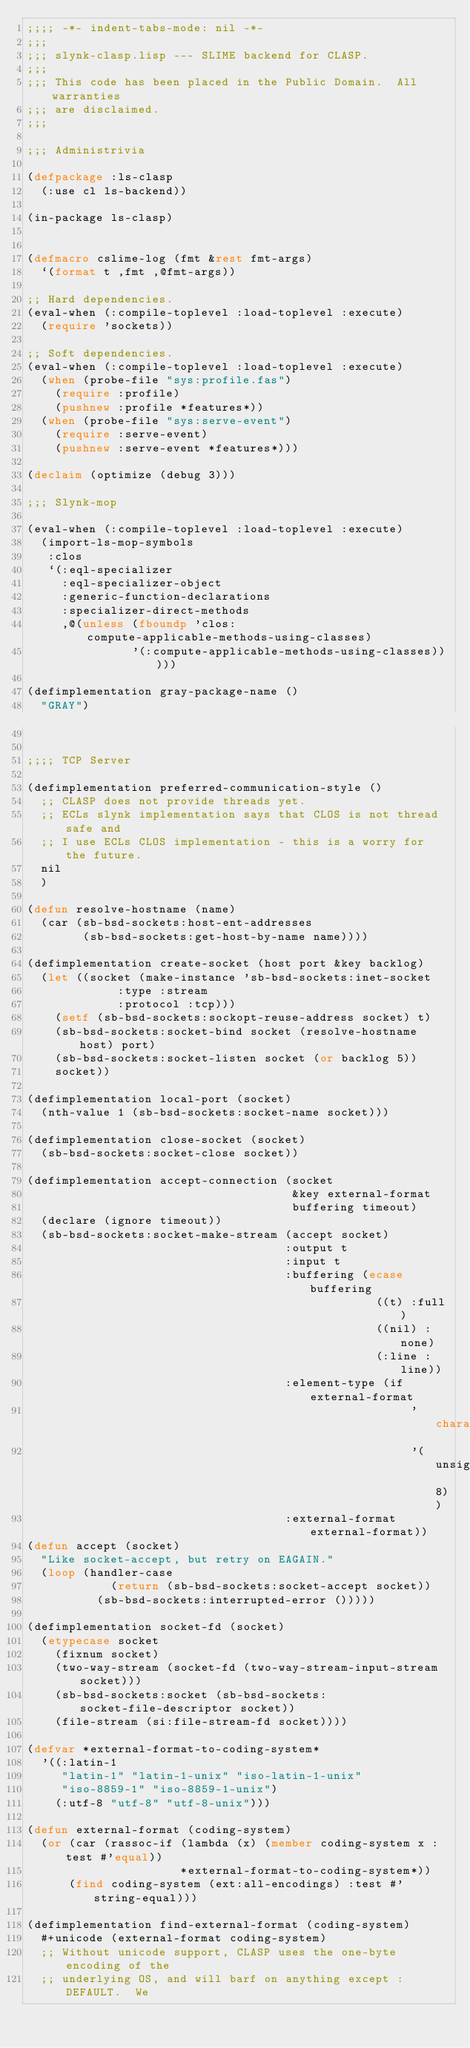Convert code to text. <code><loc_0><loc_0><loc_500><loc_500><_Lisp_>;;;; -*- indent-tabs-mode: nil -*-
;;;
;;; slynk-clasp.lisp --- SLIME backend for CLASP.
;;;
;;; This code has been placed in the Public Domain.  All warranties
;;; are disclaimed.
;;;

;;; Administrivia

(defpackage :ls-clasp
  (:use cl ls-backend))

(in-package ls-clasp)


(defmacro cslime-log (fmt &rest fmt-args)
  `(format t ,fmt ,@fmt-args))

;; Hard dependencies.
(eval-when (:compile-toplevel :load-toplevel :execute)
  (require 'sockets))

;; Soft dependencies.
(eval-when (:compile-toplevel :load-toplevel :execute)
  (when (probe-file "sys:profile.fas")
    (require :profile)
    (pushnew :profile *features*))
  (when (probe-file "sys:serve-event")
    (require :serve-event)
    (pushnew :serve-event *features*)))

(declaim (optimize (debug 3)))

;;; Slynk-mop

(eval-when (:compile-toplevel :load-toplevel :execute)
  (import-ls-mop-symbols
   :clos
   `(:eql-specializer
     :eql-specializer-object
     :generic-function-declarations
     :specializer-direct-methods
     ,@(unless (fboundp 'clos:compute-applicable-methods-using-classes)
               '(:compute-applicable-methods-using-classes)))))

(defimplementation gray-package-name ()
  "GRAY")


;;;; TCP Server

(defimplementation preferred-communication-style ()
  ;; CLASP does not provide threads yet.
  ;; ECLs slynk implementation says that CLOS is not thread safe and
  ;; I use ECLs CLOS implementation - this is a worry for the future.
  nil
  )

(defun resolve-hostname (name)
  (car (sb-bsd-sockets:host-ent-addresses
        (sb-bsd-sockets:get-host-by-name name))))

(defimplementation create-socket (host port &key backlog)
  (let ((socket (make-instance 'sb-bsd-sockets:inet-socket
			       :type :stream
			       :protocol :tcp)))
    (setf (sb-bsd-sockets:sockopt-reuse-address socket) t)
    (sb-bsd-sockets:socket-bind socket (resolve-hostname host) port)
    (sb-bsd-sockets:socket-listen socket (or backlog 5))
    socket))

(defimplementation local-port (socket)
  (nth-value 1 (sb-bsd-sockets:socket-name socket)))

(defimplementation close-socket (socket)
  (sb-bsd-sockets:socket-close socket))

(defimplementation accept-connection (socket
                                      &key external-format
                                      buffering timeout)
  (declare (ignore timeout))
  (sb-bsd-sockets:socket-make-stream (accept socket)
                                     :output t
                                     :input t
                                     :buffering (ecase buffering
                                                  ((t) :full)
                                                  ((nil) :none)
                                                  (:line :line))
                                     :element-type (if external-format
                                                       'character 
                                                       '(unsigned-byte 8))
                                     :external-format external-format))
(defun accept (socket)
  "Like socket-accept, but retry on EAGAIN."
  (loop (handler-case
            (return (sb-bsd-sockets:socket-accept socket))
          (sb-bsd-sockets:interrupted-error ()))))

(defimplementation socket-fd (socket)
  (etypecase socket
    (fixnum socket)
    (two-way-stream (socket-fd (two-way-stream-input-stream socket)))
    (sb-bsd-sockets:socket (sb-bsd-sockets:socket-file-descriptor socket))
    (file-stream (si:file-stream-fd socket))))

(defvar *external-format-to-coding-system*
  '((:latin-1
     "latin-1" "latin-1-unix" "iso-latin-1-unix" 
     "iso-8859-1" "iso-8859-1-unix")
    (:utf-8 "utf-8" "utf-8-unix")))

(defun external-format (coding-system)
  (or (car (rassoc-if (lambda (x) (member coding-system x :test #'equal))
                      *external-format-to-coding-system*))
      (find coding-system (ext:all-encodings) :test #'string-equal)))

(defimplementation find-external-format (coding-system)
  #+unicode (external-format coding-system)
  ;; Without unicode support, CLASP uses the one-byte encoding of the
  ;; underlying OS, and will barf on anything except :DEFAULT.  We</code> 